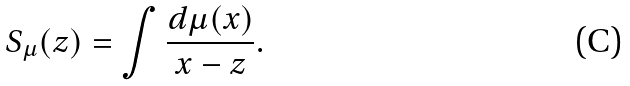<formula> <loc_0><loc_0><loc_500><loc_500>S _ { \mu } ( z ) = \int \frac { d \mu ( x ) } { x - z } .</formula> 